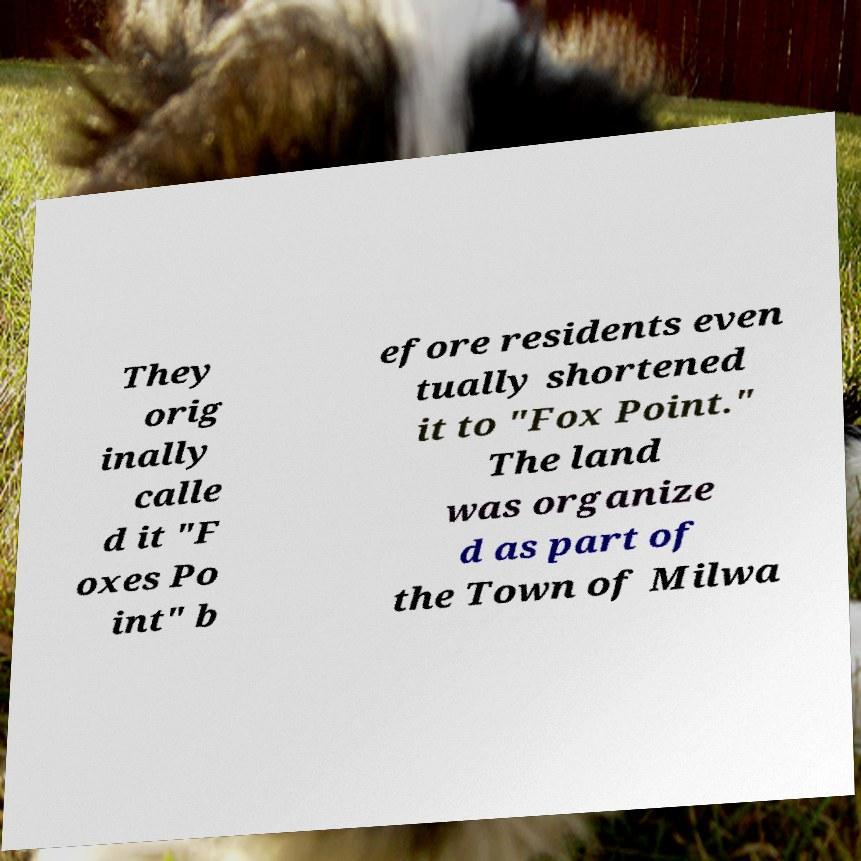For documentation purposes, I need the text within this image transcribed. Could you provide that? They orig inally calle d it "F oxes Po int" b efore residents even tually shortened it to "Fox Point." The land was organize d as part of the Town of Milwa 